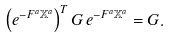Convert formula to latex. <formula><loc_0><loc_0><loc_500><loc_500>\left ( e ^ { - F ^ { a } \mathbb { X } ^ { a } } \right ) ^ { T } G \, e ^ { - F ^ { a } \mathbb { X } ^ { a } } = G .</formula> 